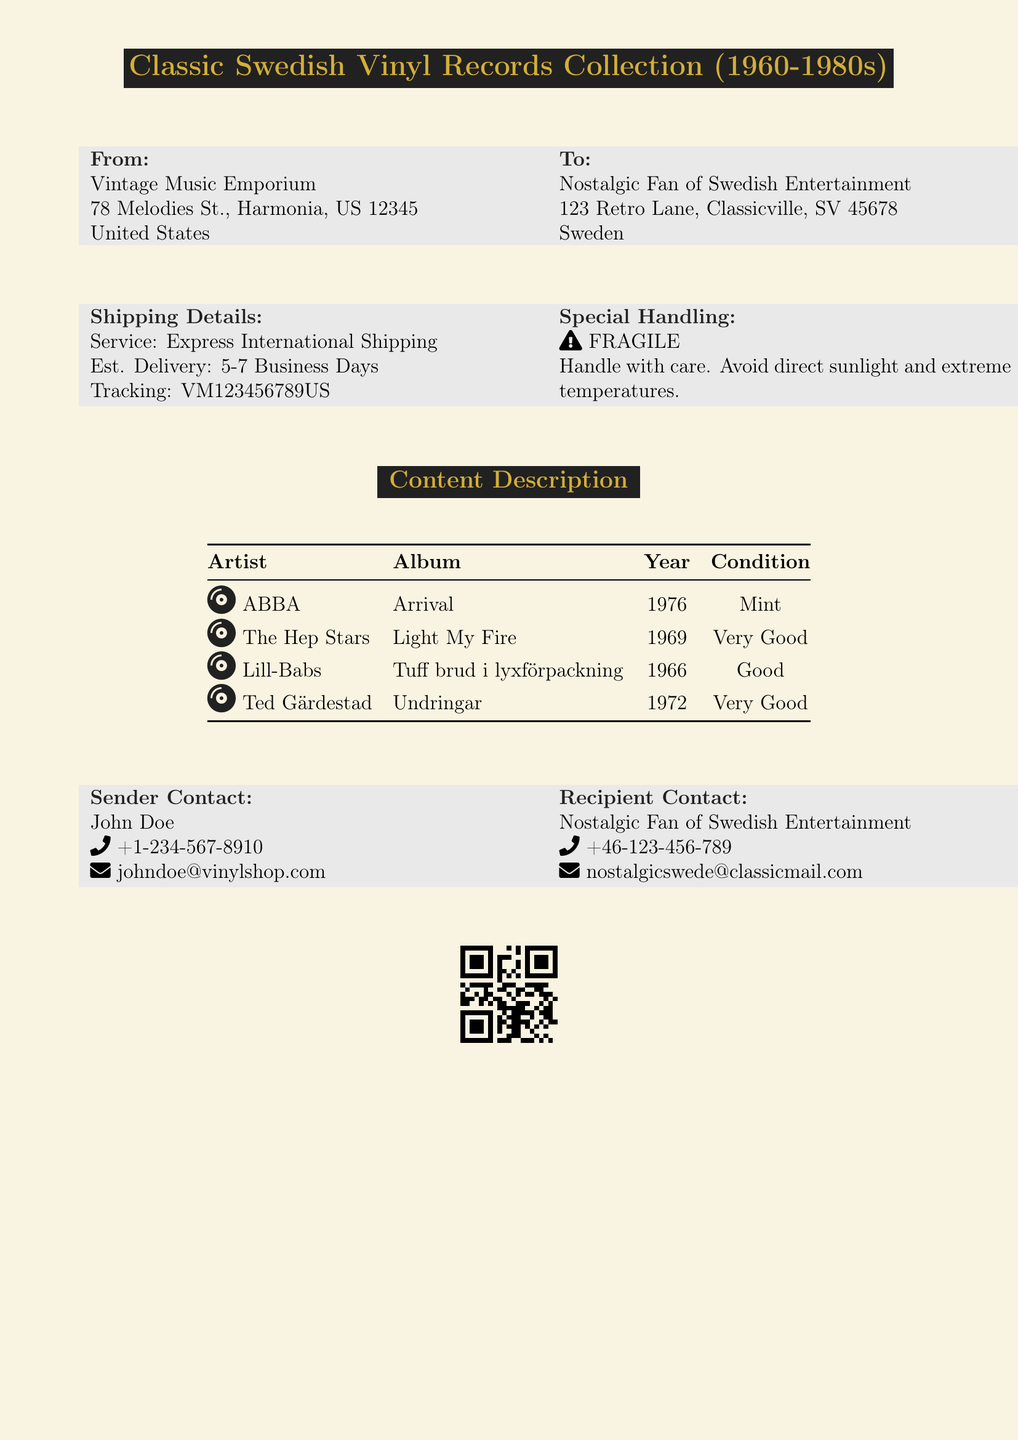What is the sender's name? The sender's name is clearly mentioned in the document.
Answer: John Doe What is the estimated delivery time? The estimated delivery time is specified within the shipping details.
Answer: 5-7 Business Days What is the recipient's address? The complete address of the recipient is provided in the document.
Answer: 123 Retro Lane, Classicville, SV 45678 What shipping service is being used? The shipping service used for this delivery is indicated in the shipping details.
Answer: Express International Shipping What is the condition of the ABBA album? The condition of the ABBA album is listed in the content description table.
Answer: Mint What type of special handling is required? Special handling instructions are specified to ensure the safety of the package.
Answer: FRAGILE How many records are listed in the content description? The number of records can be determined from the listing in the table.
Answer: 4 What is the phone number of the recipient? The phone number for contacting the recipient is provided in the contact information.
Answer: +46-123-456-789 Which year was "Tuff brud i lyxförpackning" released? The release year of the specified album can be found in the content description.
Answer: 1966 